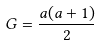<formula> <loc_0><loc_0><loc_500><loc_500>G = \frac { a ( a + 1 ) } { 2 }</formula> 